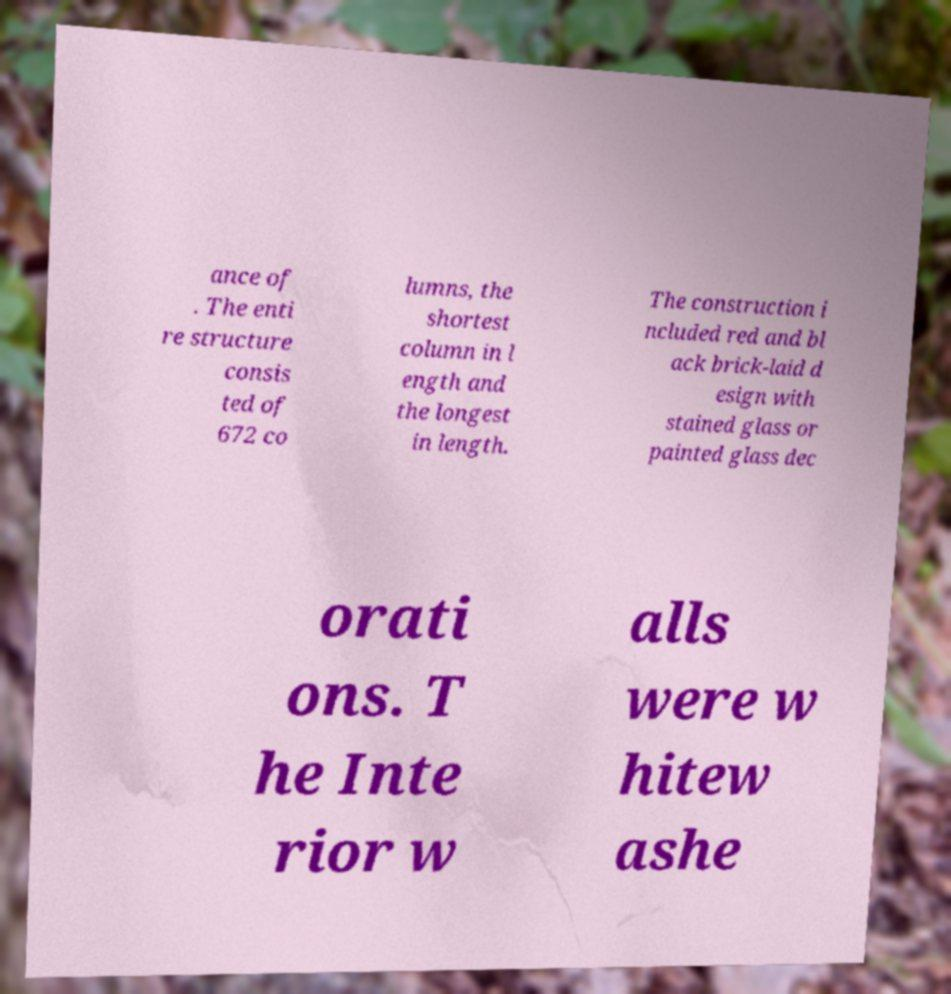Please read and relay the text visible in this image. What does it say? ance of . The enti re structure consis ted of 672 co lumns, the shortest column in l ength and the longest in length. The construction i ncluded red and bl ack brick-laid d esign with stained glass or painted glass dec orati ons. T he Inte rior w alls were w hitew ashe 